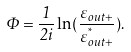<formula> <loc_0><loc_0><loc_500><loc_500>\Phi = \frac { 1 } { 2 i } \ln ( \frac { \varepsilon _ { o u t + } } { \varepsilon _ { o u t + } ^ { ^ { * } } } ) .</formula> 